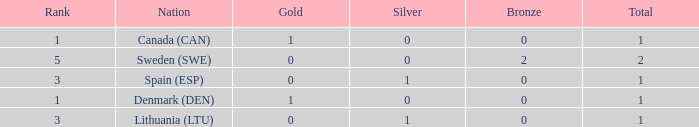What is the number of gold medals for Lithuania (ltu), when the total is more than 1? None. Give me the full table as a dictionary. {'header': ['Rank', 'Nation', 'Gold', 'Silver', 'Bronze', 'Total'], 'rows': [['1', 'Canada (CAN)', '1', '0', '0', '1'], ['5', 'Sweden (SWE)', '0', '0', '2', '2'], ['3', 'Spain (ESP)', '0', '1', '0', '1'], ['1', 'Denmark (DEN)', '1', '0', '0', '1'], ['3', 'Lithuania (LTU)', '0', '1', '0', '1']]} 